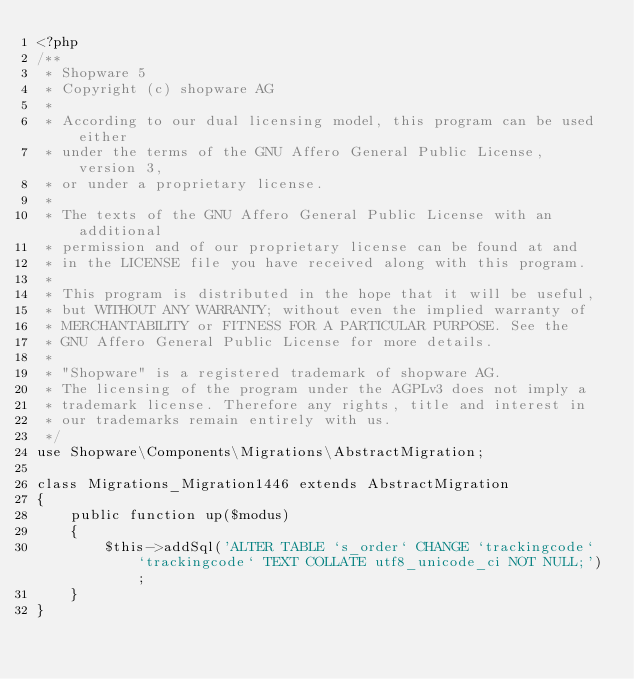Convert code to text. <code><loc_0><loc_0><loc_500><loc_500><_PHP_><?php
/**
 * Shopware 5
 * Copyright (c) shopware AG
 *
 * According to our dual licensing model, this program can be used either
 * under the terms of the GNU Affero General Public License, version 3,
 * or under a proprietary license.
 *
 * The texts of the GNU Affero General Public License with an additional
 * permission and of our proprietary license can be found at and
 * in the LICENSE file you have received along with this program.
 *
 * This program is distributed in the hope that it will be useful,
 * but WITHOUT ANY WARRANTY; without even the implied warranty of
 * MERCHANTABILITY or FITNESS FOR A PARTICULAR PURPOSE. See the
 * GNU Affero General Public License for more details.
 *
 * "Shopware" is a registered trademark of shopware AG.
 * The licensing of the program under the AGPLv3 does not imply a
 * trademark license. Therefore any rights, title and interest in
 * our trademarks remain entirely with us.
 */
use Shopware\Components\Migrations\AbstractMigration;

class Migrations_Migration1446 extends AbstractMigration
{
    public function up($modus)
    {
        $this->addSql('ALTER TABLE `s_order` CHANGE `trackingcode` `trackingcode` TEXT COLLATE utf8_unicode_ci NOT NULL;');
    }
}
</code> 